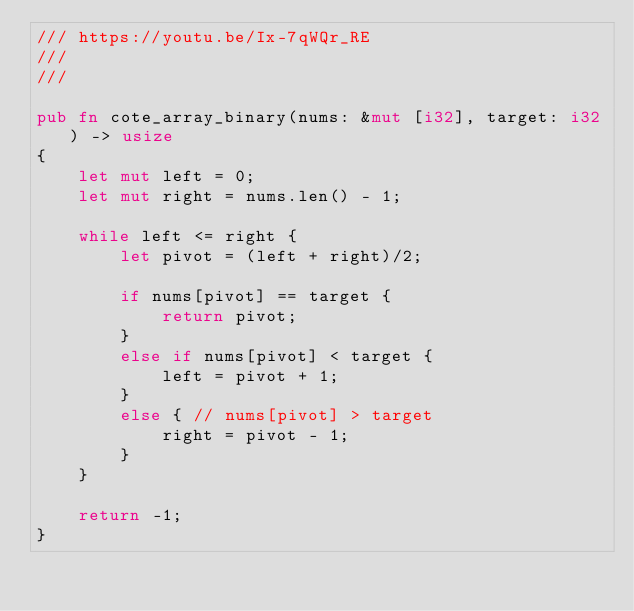<code> <loc_0><loc_0><loc_500><loc_500><_Rust_>/// https://youtu.be/Ix-7qWQr_RE
///
///

pub fn cote_array_binary(nums: &mut [i32], target: i32) -> usize
{
    let mut left = 0;
    let mut right = nums.len() - 1;

    while left <= right {
        let pivot = (left + right)/2;

        if nums[pivot] == target {
            return pivot;
        }
        else if nums[pivot] < target {
            left = pivot + 1;
        }
        else { // nums[pivot] > target
            right = pivot - 1;
        }
    }
    
    return -1;
}
</code> 